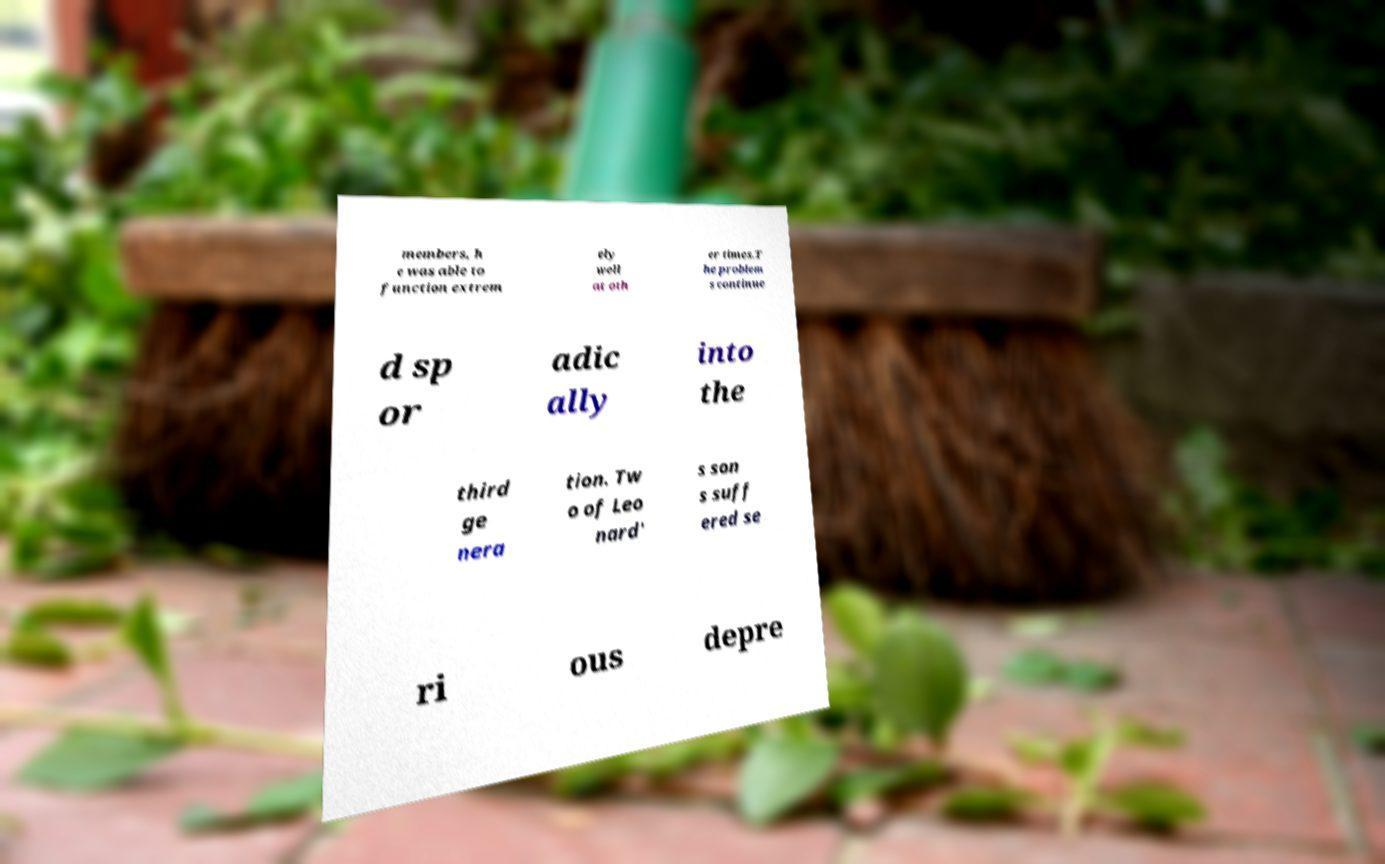I need the written content from this picture converted into text. Can you do that? members, h e was able to function extrem ely well at oth er times.T he problem s continue d sp or adic ally into the third ge nera tion. Tw o of Leo nard' s son s suff ered se ri ous depre 